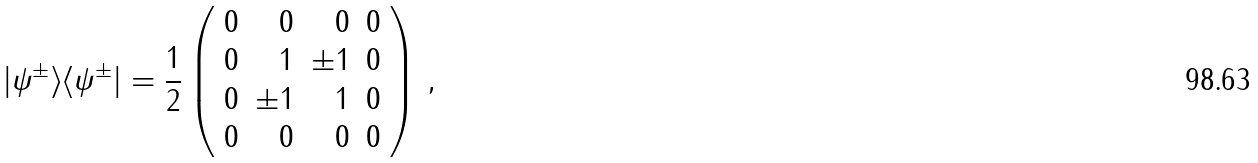<formula> <loc_0><loc_0><loc_500><loc_500>| \psi ^ { \pm } \rangle \langle \psi ^ { \pm } | = \frac { 1 } { 2 } \left ( \begin{array} { r r r r } 0 & 0 & 0 & 0 \\ 0 & 1 & \pm 1 & 0 \\ 0 & \pm 1 & 1 & 0 \\ 0 & 0 & 0 & 0 \end{array} \right ) \, ,</formula> 